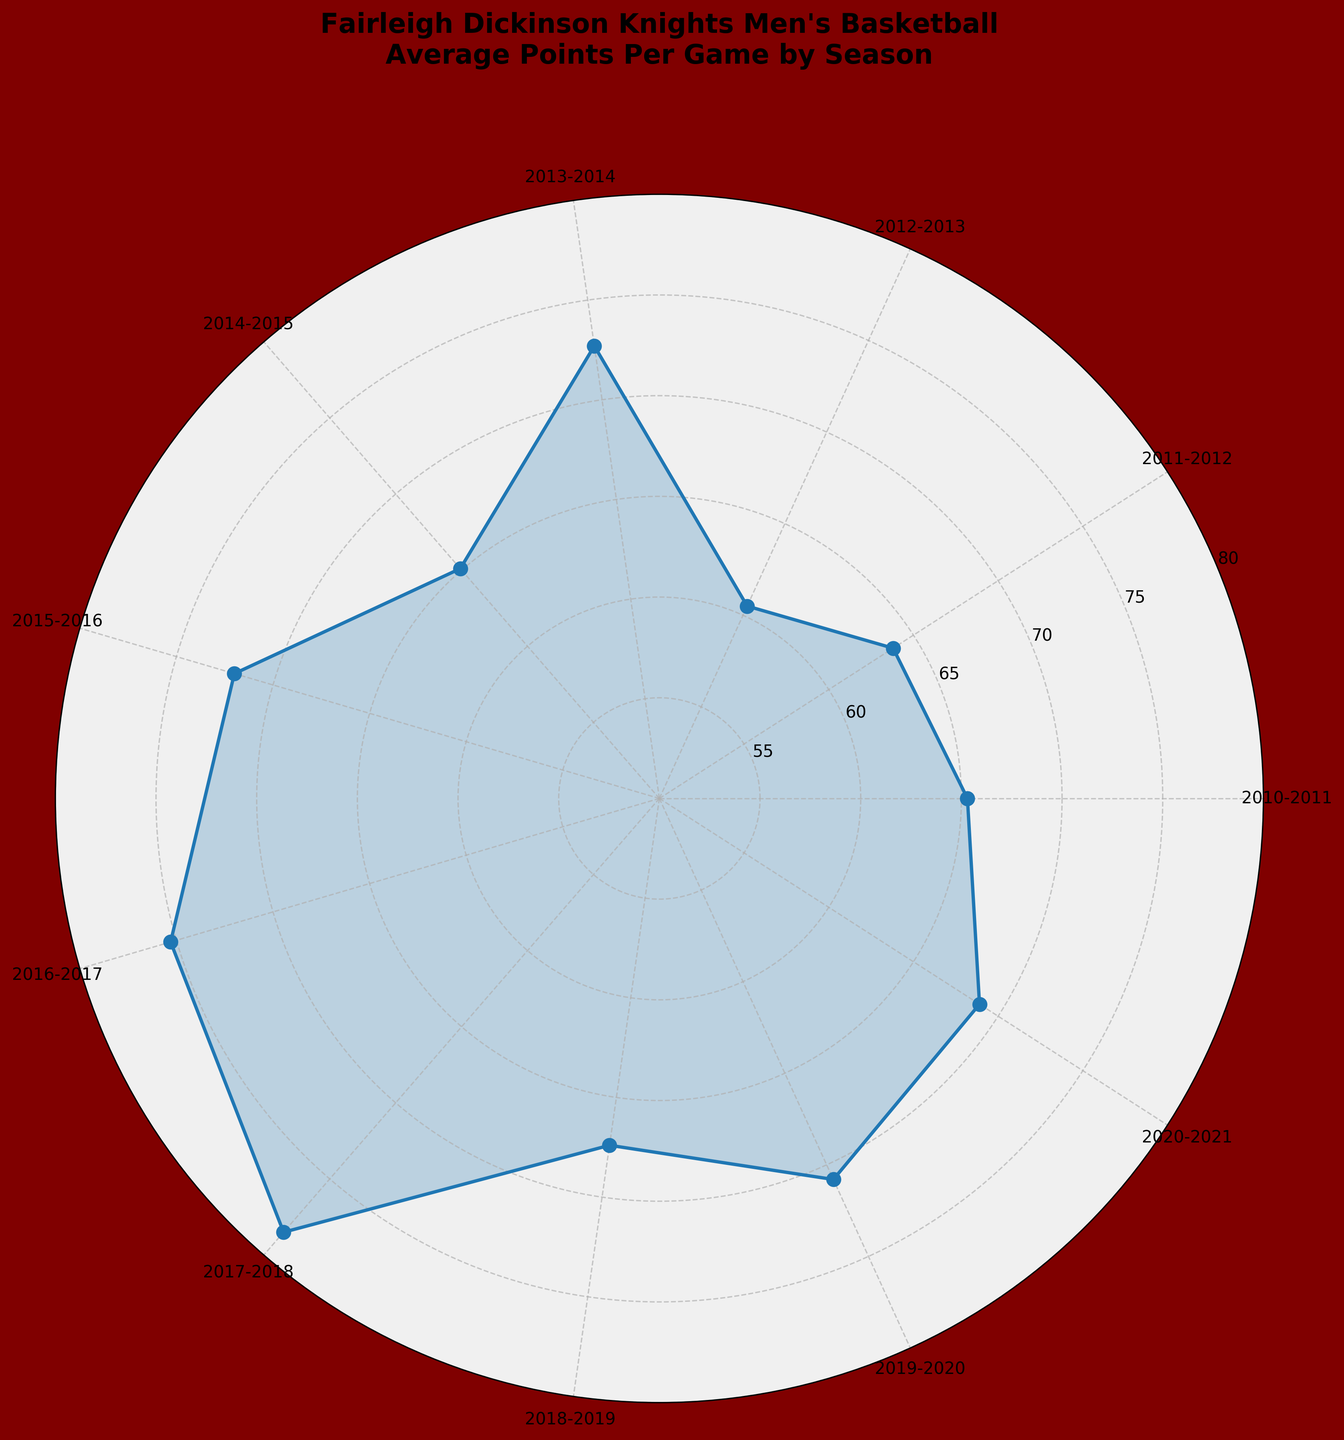What is the title of the chart? The title is usually the text placed at the top of a chart and indicates what the chart is about.
Answer: Fairleigh Dickinson Knights Men's Basketball Average Points Per Game by Season How many seasons are represented in the chart? To find the number of seasons, count the number of labeled tick marks around the polar plot.
Answer: 11 What was the average points per game in the 2013-2014 season? Locate the label for the 2013-2014 season on the chart and then look at the corresponding value indicated by the plotted line.
Answer: 72.7 Which season's average points per game is the highest? Identify the peak of the plotted line and read the corresponding season label.
Answer: 2017-2018 What is the range of the average points per game over the seasons? To calculate the range, find the maximum and minimum values of the plotted line and subtract the minimum from the maximum. Maximum is 78.5 (2017-2018) and minimum is 60.5 (2012-2013). The range is 78.5 - 60.5 = 18.0.
Answer: 18.0 Which seasons had average points per game greater than 70? Look at the plotted line and identify which segments are above the 70-mark on the radial axis, then read the corresponding season labels.
Answer: 2013-2014, 2015-2016, 2016-2017, 2017-2018, 2019-2020 What is the difference in average points per game between the 2015-2016 and 2018-2019 seasons? Find the values for both seasons on the chart and subtract the 2018-2019 value from the 2015-2016 value. 72.0 (2015-2016) - 67.4 (2018-2019) = 4.6.
Answer: 4.6 What trend can you observe from 2012-2013 to 2017-2018? Follow the plotted line from 2012-2013 to 2017-2018 and describe the general direction or pattern observed.
Answer: Increasing trend How does the average points per game in 2020-2021 compare to the previous season? Locate both seasons on the chart, compare the plotted values, and note whether 2020-2021 is higher or lower than 2019-2020.
Answer: Lower What is the median value of average points per game over the seasons? List all the values, sort them in ascending order, and find the middle value. Values: 60.5, 63.8, 65.1, 65.3, 67.4, 68.9, 70.8, 72.0, 72.7, 75.3, 78.5. Median value is 68.9.
Answer: 68.9 